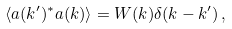<formula> <loc_0><loc_0><loc_500><loc_500>\langle a ( k ^ { \prime } ) ^ { \ast } a ( k ) \rangle = W ( k ) \delta ( k - k ^ { \prime } ) \, ,</formula> 